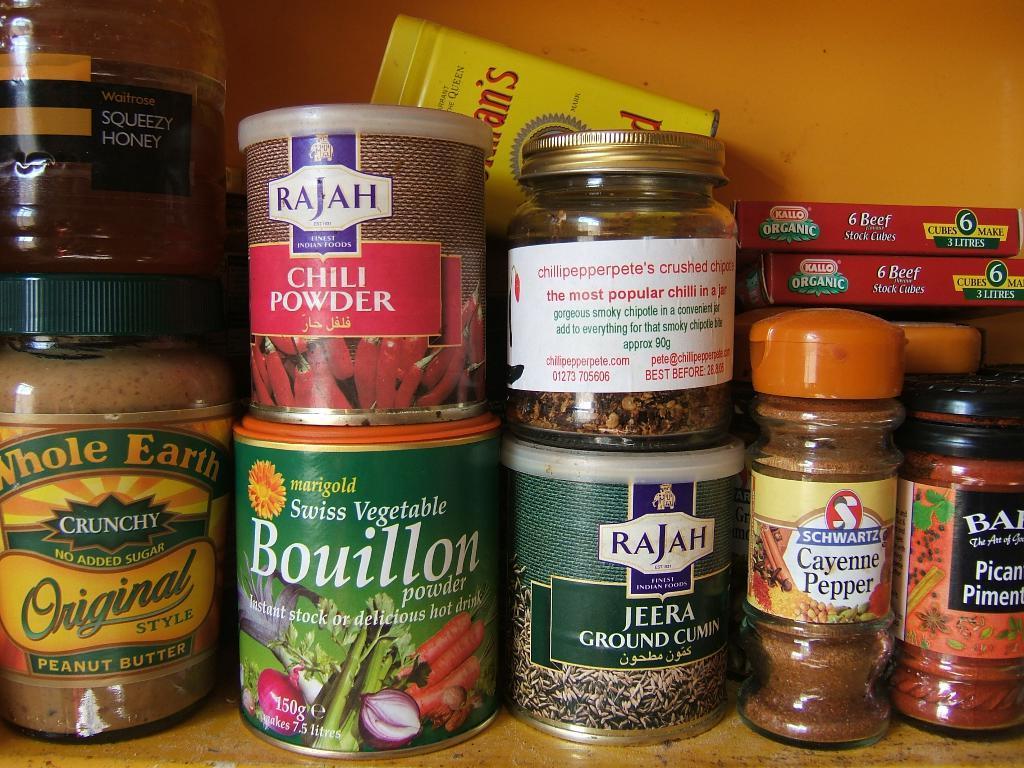In one or two sentences, can you explain what this image depicts? This image consists of bottles, jars and packets on a shelf. In the background I can see a wall. This image is taken may be in a room. 